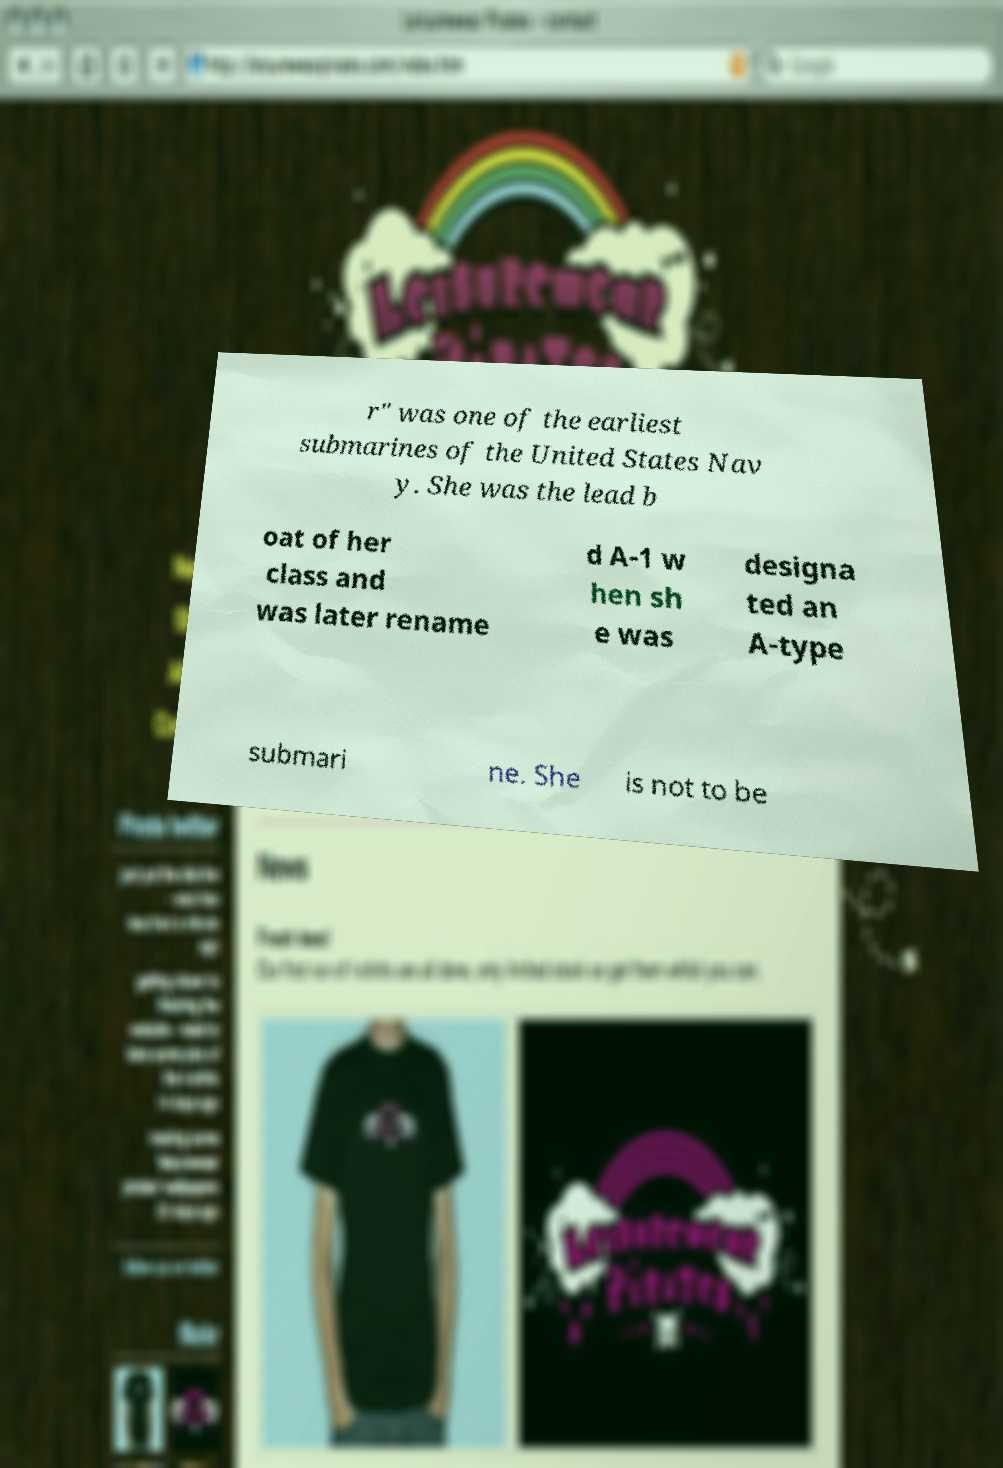Please read and relay the text visible in this image. What does it say? r" was one of the earliest submarines of the United States Nav y. She was the lead b oat of her class and was later rename d A-1 w hen sh e was designa ted an A-type submari ne. She is not to be 